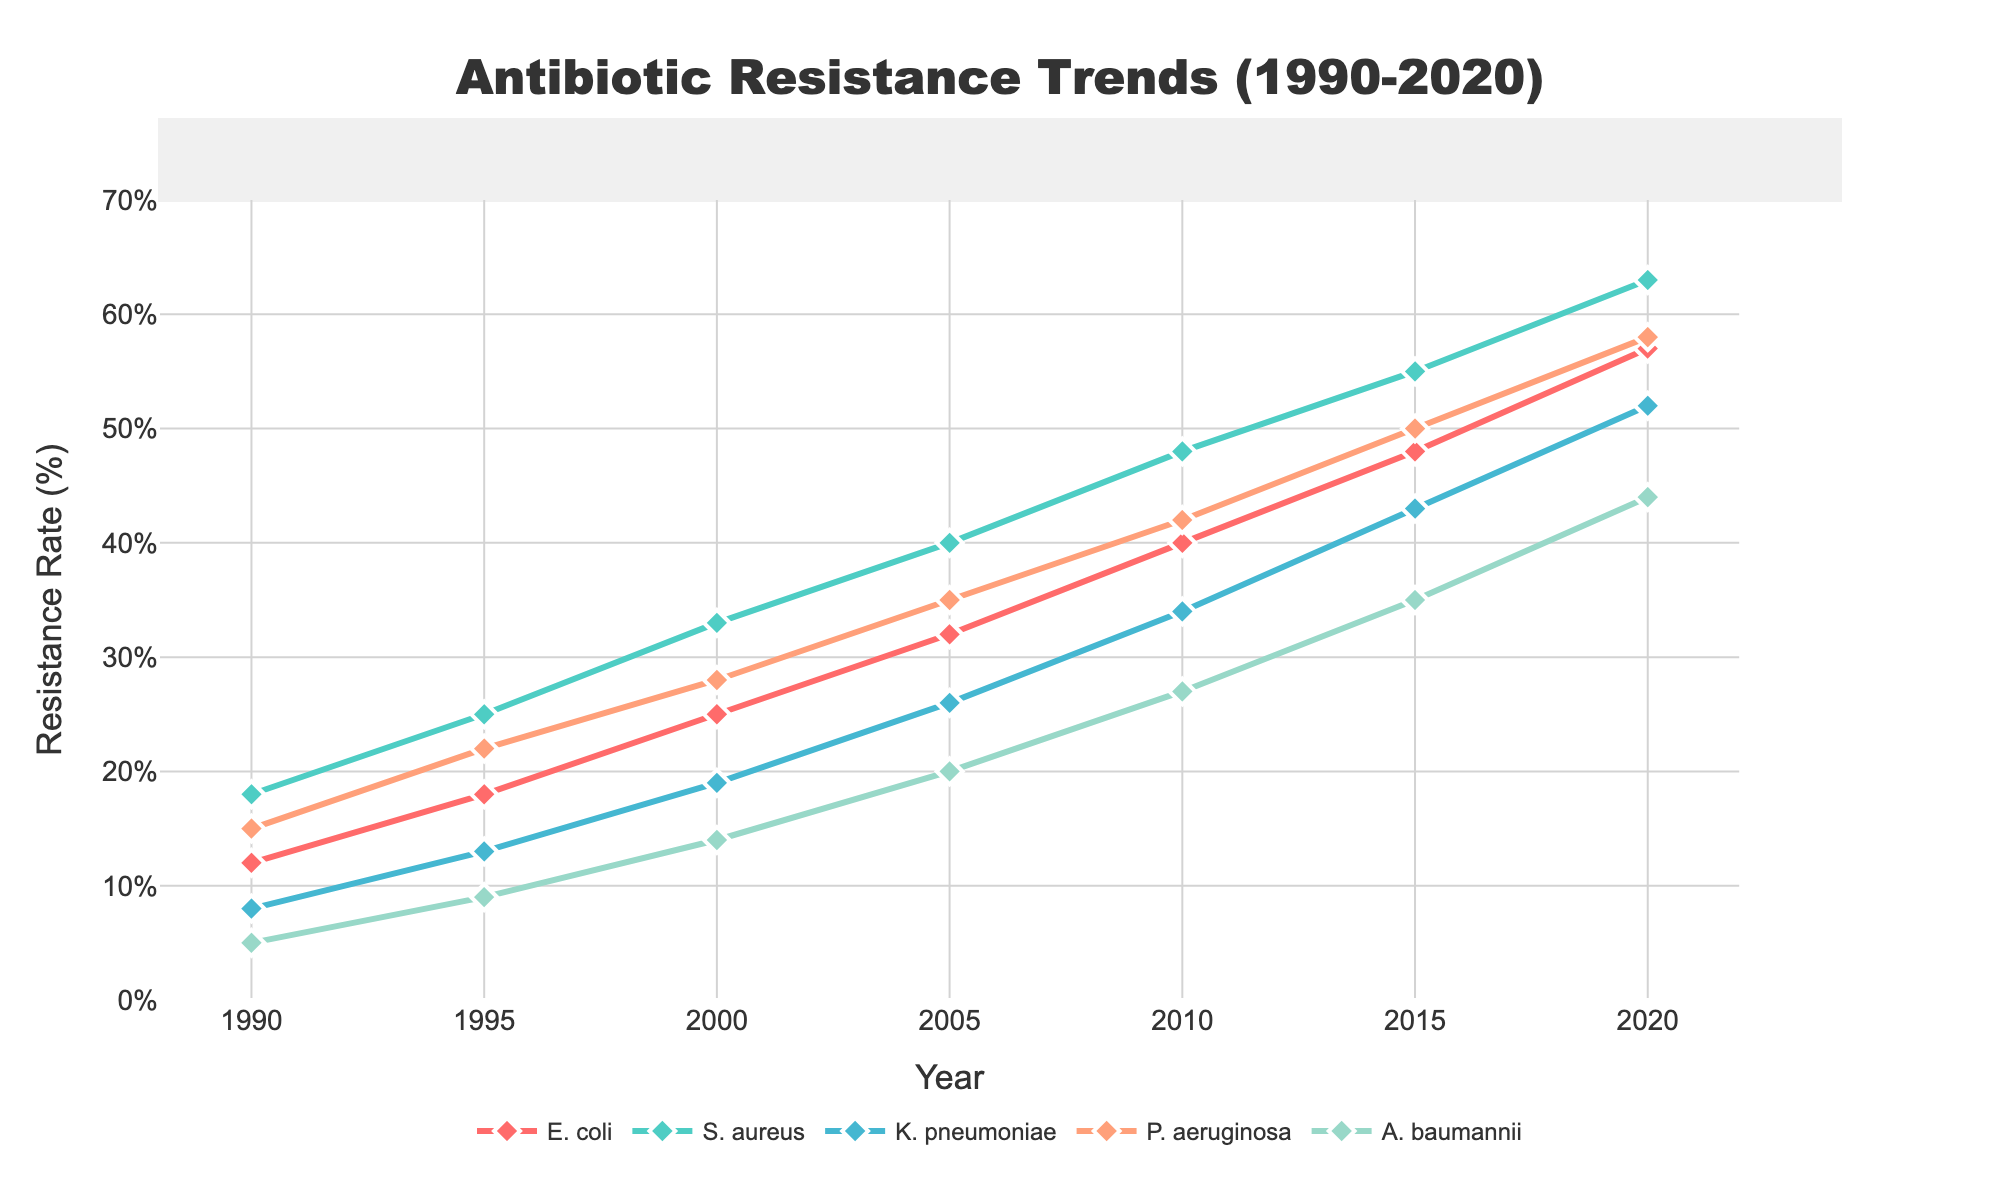What is the overall trend for antibiotic resistance in E. coli from 1990 to 2020? To identify the overall trend, observe the values for E. coli from 1990 (12%) to 2020 (57%). The resistance rate shows an increasing trend over the three decades.
Answer: Increasing Which bacterial infection had the highest antibiotic resistance rate in 2020? Check the resistance rates for all bacterial infections in the year 2020. The highest value is for S. aureus at 63%.
Answer: S. aureus Compare the resistance rate of K. pneumoniae and A. baumannii in the year 2005. Which one was higher? Look at the values for K. pneumoniae (26%) and A. baumannii (20%) in 2005. K. pneumoniae had a higher resistance rate than A. baumannii.
Answer: K. pneumoniae How much did the resistance rate of P. aeruginosa increase from 1990 to 2000? Subtract the resistance rate of P. aeruginosa in 1990 (15%) from its resistance rate in 2000 (28%): 28% - 15% = 13%.
Answer: 13% In which year did A. baumannii show a resistance rate of over 10% for the first time? Check the values for A. baumannii starting from 1990. The resistance rate first exceeded 10% in 1995 (9% to 14%).
Answer: 2000 What is the difference in the resistance rate between E. coli and S. aureus in 2010? Subtract the resistance rate of E. coli in 2010 (40%) from S. aureus in 2010 (48%): 48% - 40% = 8%.
Answer: 8% Between 1990 and 2020, for which bacterium did the resistance rate change the most? Calculate the difference for each bacterium from 1990 to 2020. E. coli: 57%-12% = 45%, S. aureus: 63%-18% = 45%, K. pneumoniae: 52%-8% = 44%, P. aeruginosa: 58%-15% = 43%, A. baumannii: 44%-5% = 39%. S. aureus and E. coli both had the largest change of 45%.
Answer: E. coli and S. aureus What is the average resistance rate of all bacteria in the year 2000? Add the resistance rates for all bacteria in the year 2000 and divide by the number of bacteria. (25%+33%+19%+28%+14%)/5 = 23.8%.
Answer: 23.8% Which bacterial infection had the steepest increase in resistance rate from 1990 to 1995? Calculate the increase for each bacteria from 1990 to 1995 and compare them. E. coli: 18%-12% = 6%, S. aureus: 25%-18% = 7%, K. pneumoniae: 13%-8% = 5%, P. aeruginosa: 22%-15% = 7%, A. baumannii: 9%-5% = 4%. Both S. aureus and P. aeruginosa had the steepest increase of 7%.
Answer: S. aureus and P. aeruginosa How many years did it take for S. aureus to double its resistance rate from the 1990 value? In 1990, the resistance rate was 18%. Double this is 36%. The first year where S. aureus reached or exceeded 36% was 2005. Calculate the difference: 2005 - 1990 = 15 years.
Answer: 15 years 